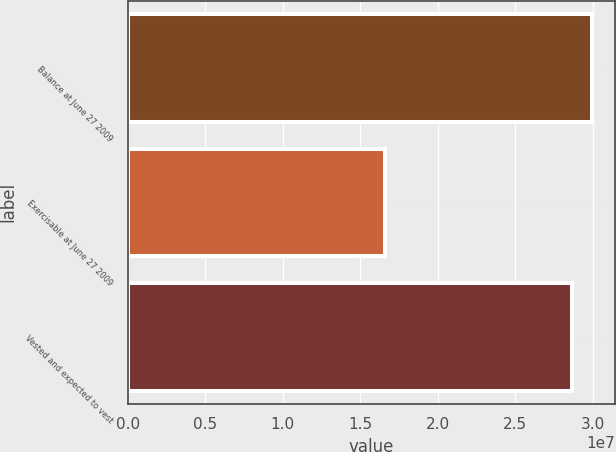<chart> <loc_0><loc_0><loc_500><loc_500><bar_chart><fcel>Balance at June 27 2009<fcel>Exercisable at June 27 2009<fcel>Vested and expected to vest<nl><fcel>2.99577e+07<fcel>1.66179e+07<fcel>2.86595e+07<nl></chart> 